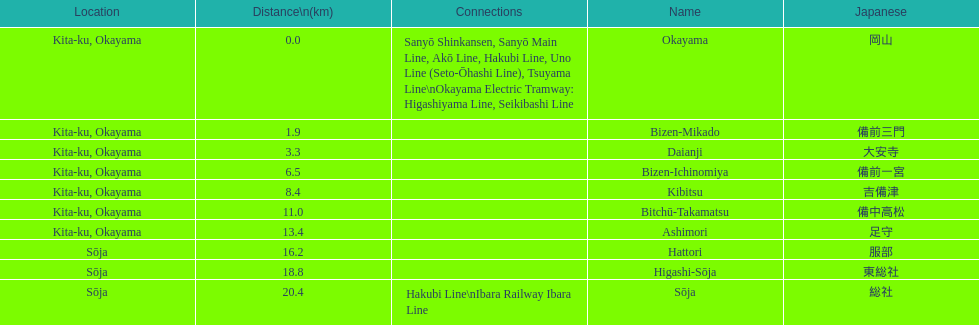What are all the stations on the kibi line? Okayama, Bizen-Mikado, Daianji, Bizen-Ichinomiya, Kibitsu, Bitchū-Takamatsu, Ashimori, Hattori, Higashi-Sōja, Sōja. What are the distances of these stations from the start of the line? 0.0, 1.9, 3.3, 6.5, 8.4, 11.0, 13.4, 16.2, 18.8, 20.4. Of these, which is larger than 1 km? 1.9, 3.3, 6.5, 8.4, 11.0, 13.4, 16.2, 18.8, 20.4. Of these, which is smaller than 2 km? 1.9. Which station is this distance from the start of the line? Bizen-Mikado. 